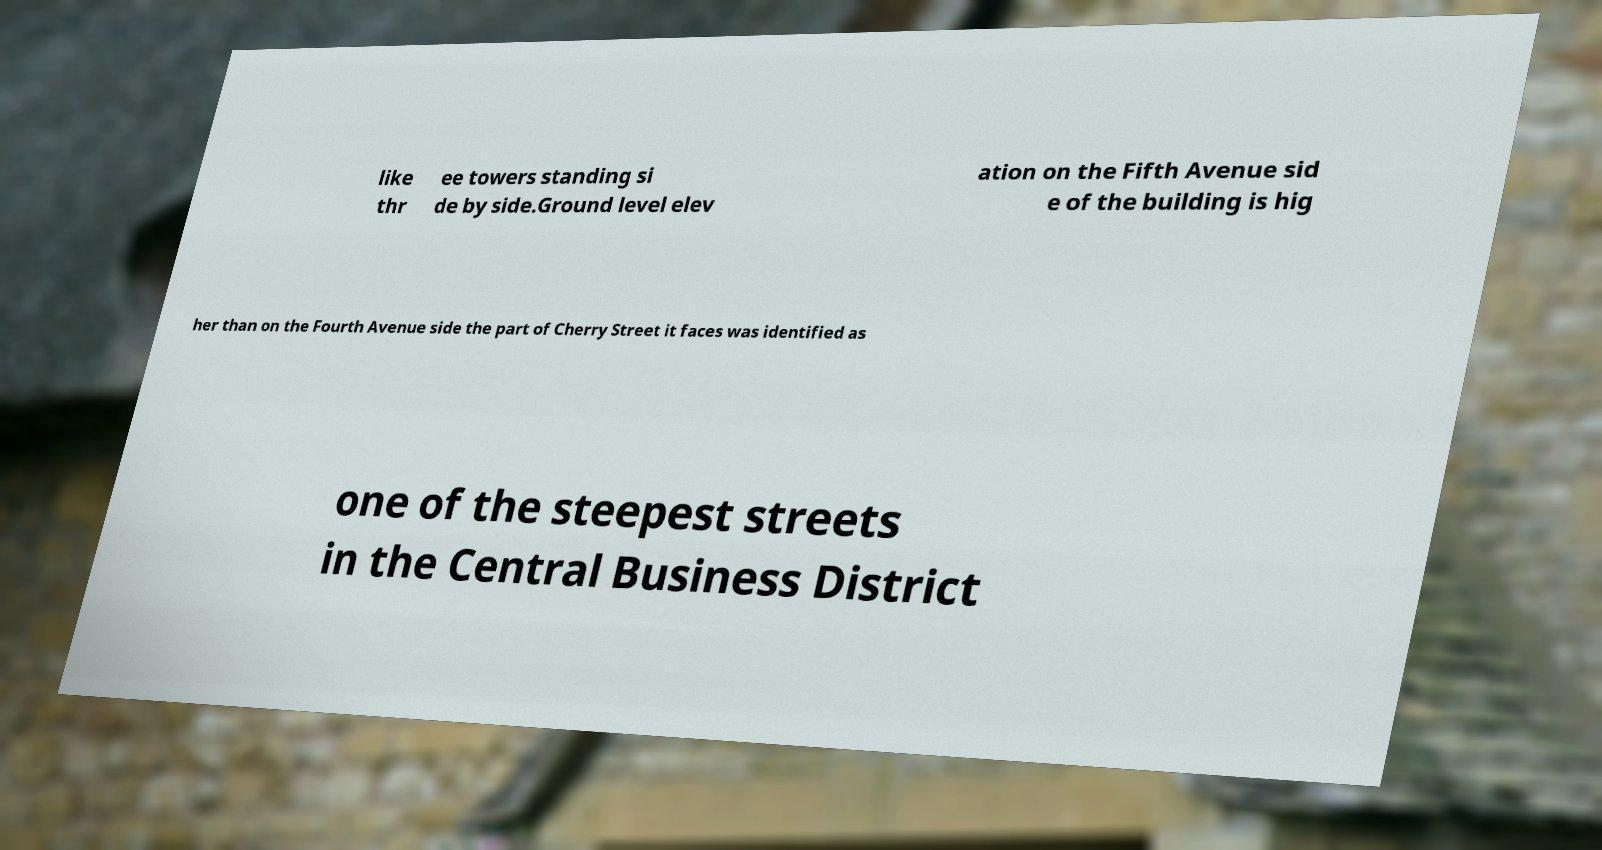Could you assist in decoding the text presented in this image and type it out clearly? like thr ee towers standing si de by side.Ground level elev ation on the Fifth Avenue sid e of the building is hig her than on the Fourth Avenue side the part of Cherry Street it faces was identified as one of the steepest streets in the Central Business District 